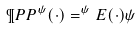<formula> <loc_0><loc_0><loc_500><loc_500>\P P P ^ { \psi } ( \cdot ) = ^ { \psi } { E ( \cdot ) \psi }</formula> 